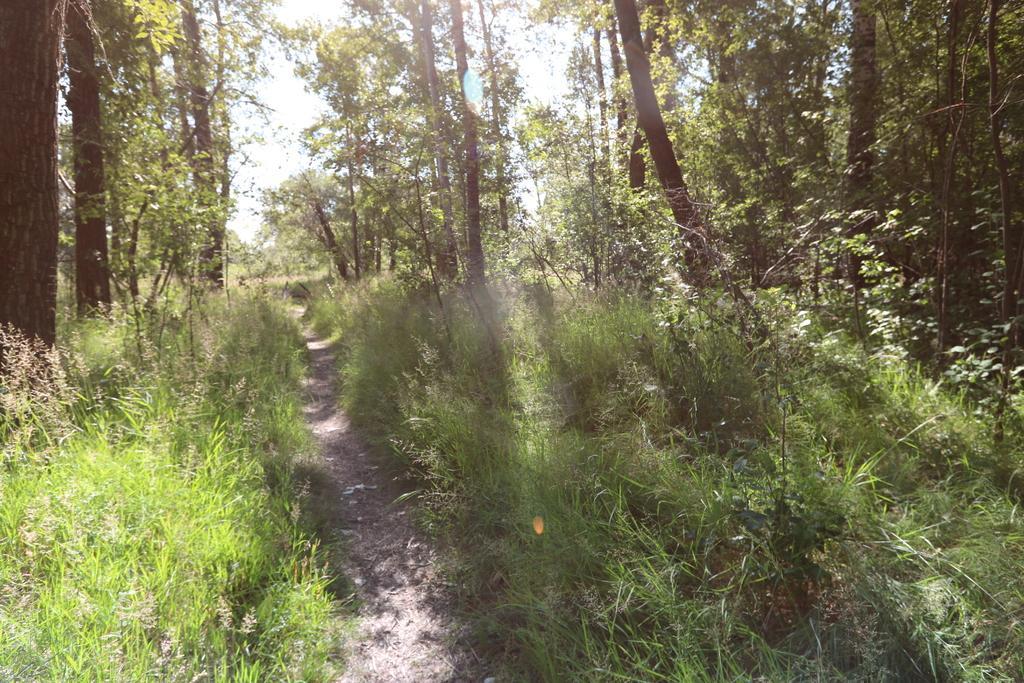Can you describe this image briefly? In the image there is a path in the middle with plants and trees on either of it and above its sky. 